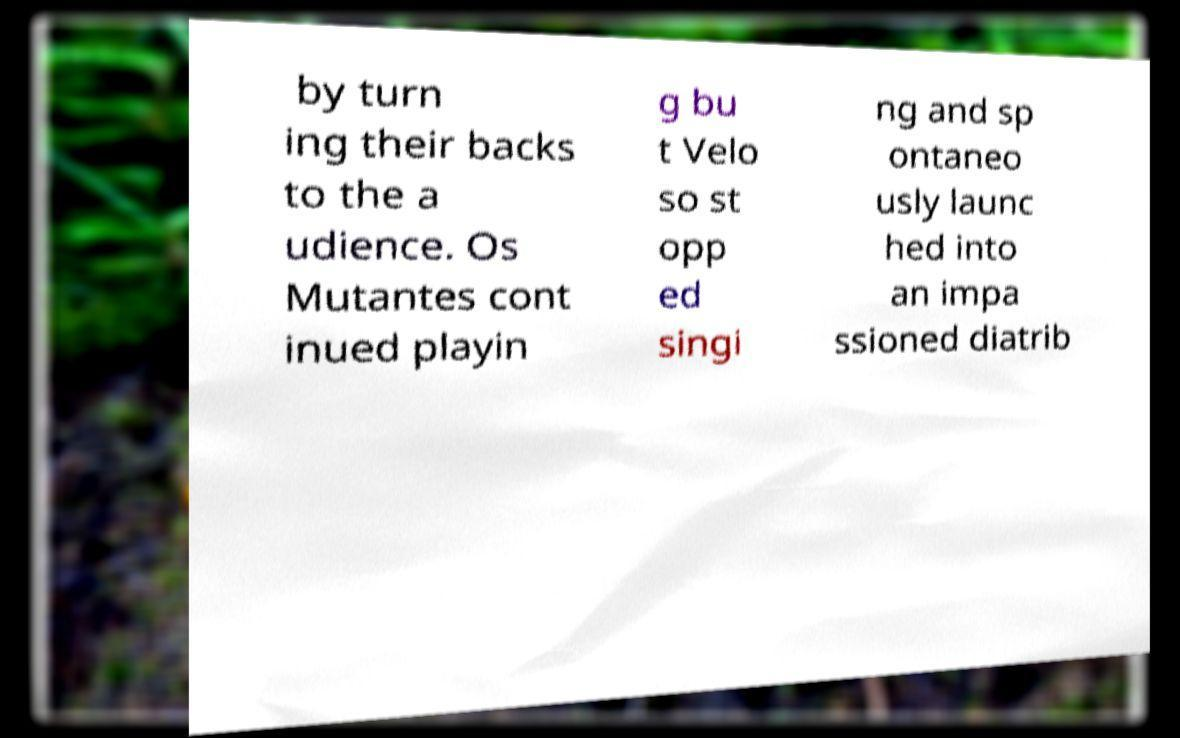Please identify and transcribe the text found in this image. by turn ing their backs to the a udience. Os Mutantes cont inued playin g bu t Velo so st opp ed singi ng and sp ontaneo usly launc hed into an impa ssioned diatrib 